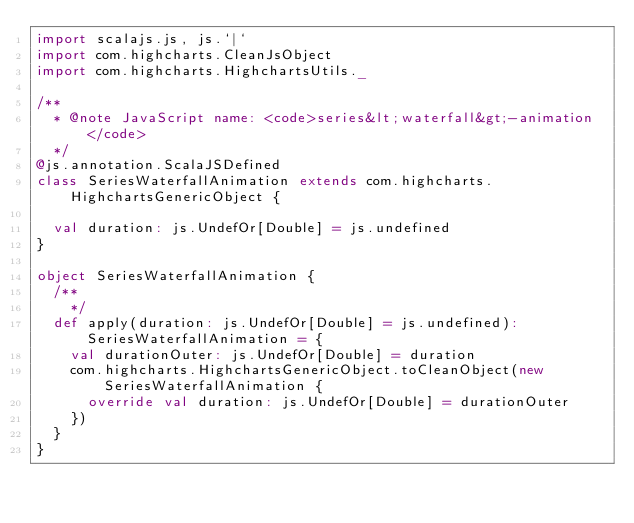<code> <loc_0><loc_0><loc_500><loc_500><_Scala_>import scalajs.js, js.`|`
import com.highcharts.CleanJsObject
import com.highcharts.HighchartsUtils._

/**
  * @note JavaScript name: <code>series&lt;waterfall&gt;-animation</code>
  */
@js.annotation.ScalaJSDefined
class SeriesWaterfallAnimation extends com.highcharts.HighchartsGenericObject {

  val duration: js.UndefOr[Double] = js.undefined
}

object SeriesWaterfallAnimation {
  /**
    */
  def apply(duration: js.UndefOr[Double] = js.undefined): SeriesWaterfallAnimation = {
    val durationOuter: js.UndefOr[Double] = duration
    com.highcharts.HighchartsGenericObject.toCleanObject(new SeriesWaterfallAnimation {
      override val duration: js.UndefOr[Double] = durationOuter
    })
  }
}
</code> 